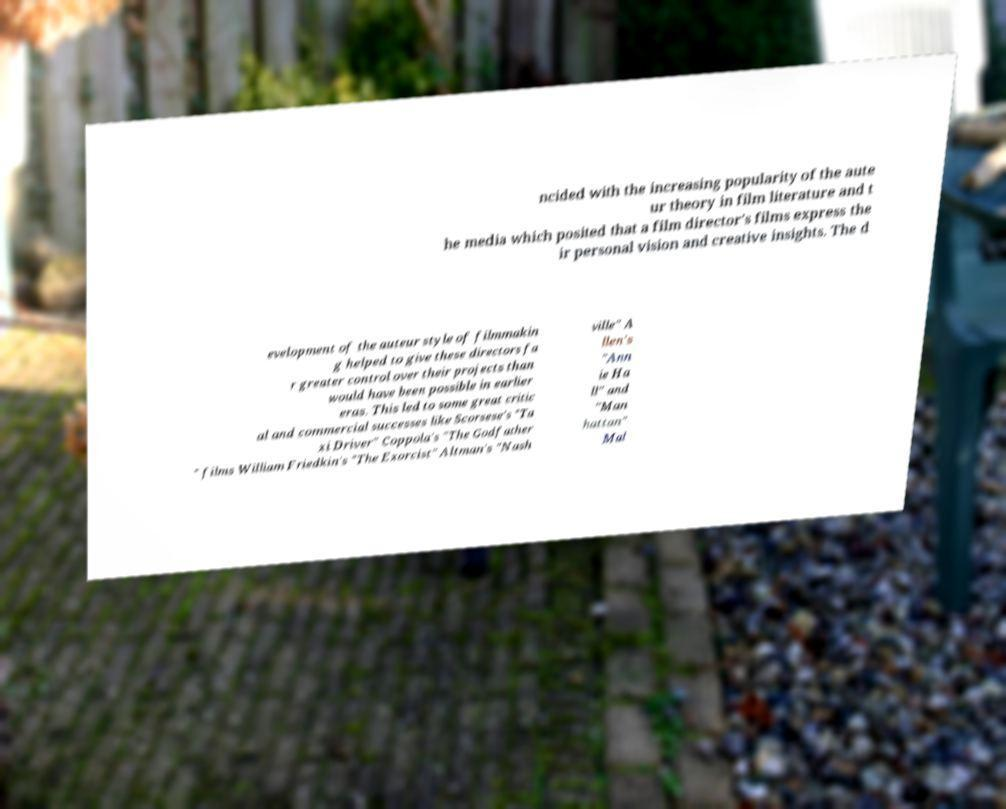Please identify and transcribe the text found in this image. ncided with the increasing popularity of the aute ur theory in film literature and t he media which posited that a film director's films express the ir personal vision and creative insights. The d evelopment of the auteur style of filmmakin g helped to give these directors fa r greater control over their projects than would have been possible in earlier eras. This led to some great critic al and commercial successes like Scorsese's "Ta xi Driver" Coppola's "The Godfather " films William Friedkin's "The Exorcist" Altman's "Nash ville" A llen's "Ann ie Ha ll" and "Man hattan" Mal 